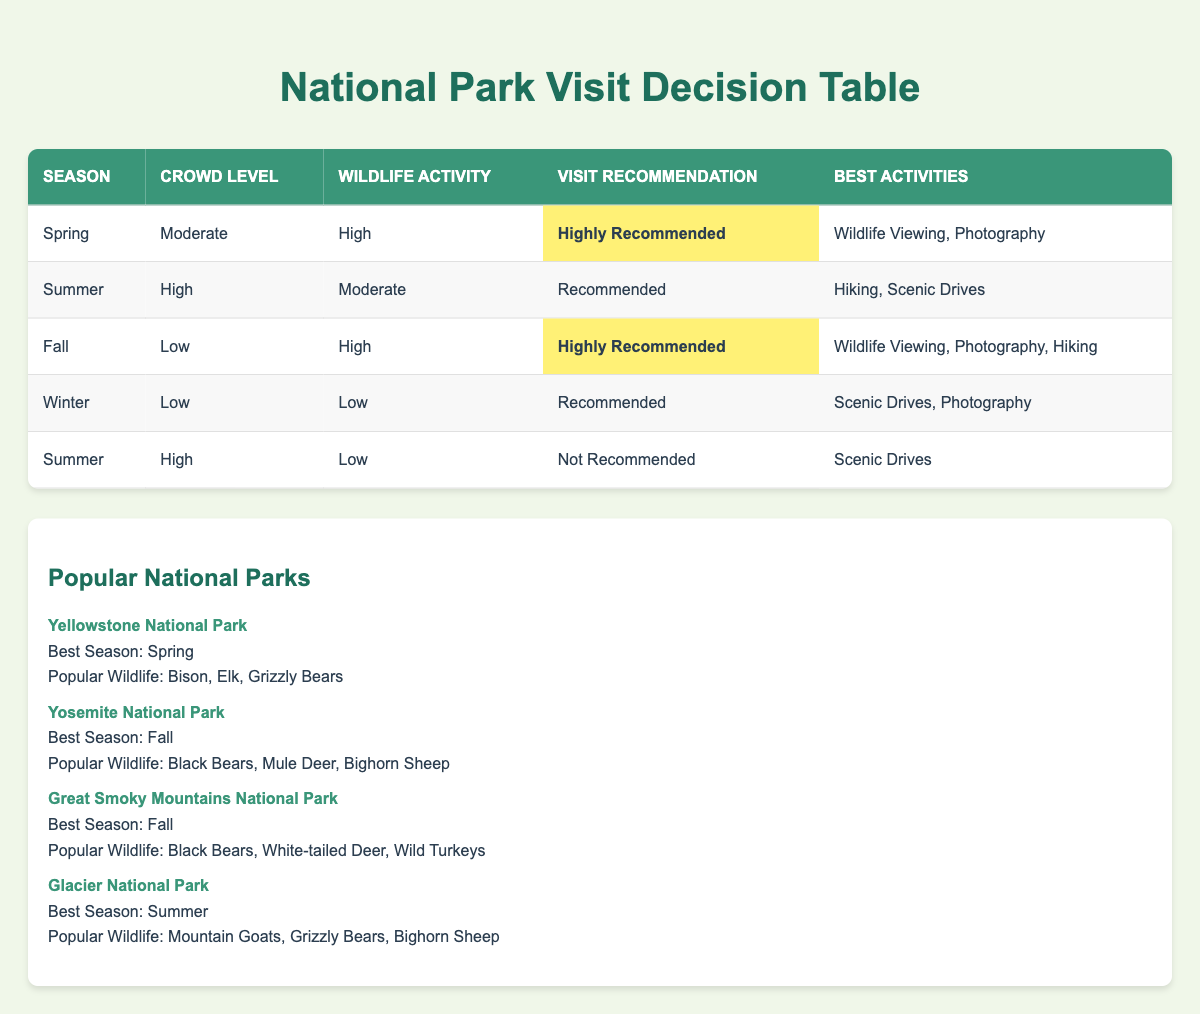What is the best season to visit Yellowstone National Park? According to the table, Yellowstone National Park's best season is listed as Spring.
Answer: Spring Which visit recommendation appears for Fall with a low crowd level and high wildlife activity? The table shows that for Fall with a low crowd level and high wildlife activity, the visit recommendation is Highly Recommended.
Answer: Highly Recommended How many best activities are recommended for visiting during Spring? The table indicates that during Spring, the best activities are Wildlife Viewing and Photography, which makes a total of 2 activities.
Answer: 2 Is it recommended to visit a national park during Summer when the crowd level is high and wildlife activity is low? The table specifies that visiting a national park during Summer with a high crowd level and low wildlife activity is Not Recommended.
Answer: No What are the best activities for Fall when the crowd level is low and wildlife activity is high? For Fall with a low crowd level and high wildlife activity, the table lists the best activities as Wildlife Viewing, Photography, and Hiking.
Answer: Wildlife Viewing, Photography, Hiking How many national parks have Fall as the best season? From the national parks listed, both Yosemite National Park and Great Smoky Mountains National Park have Fall as their best season, so there are 2 parks.
Answer: 2 Which season has the highest wildlife activity recommendation? Upon reviewing the table, Spring and Fall both have a high wildlife activity recommendation, but only Fall has a low crowd level along with it, indicating it might be the best time for wildlife viewing.
Answer: Fall If you wanted to engage in wildlife viewing and photography, which season would you recommend? The table shows that both Spring and Fall provide opportunities for wildlife viewing and photography, with Fall being highly recommended for those activities.
Answer: Fall What is the recommended visit activity for Winter? According to the table, the recommended visit activities for Winter are Scenic Drives and Photography, making them the best choices for that season.
Answer: Scenic Drives, Photography 